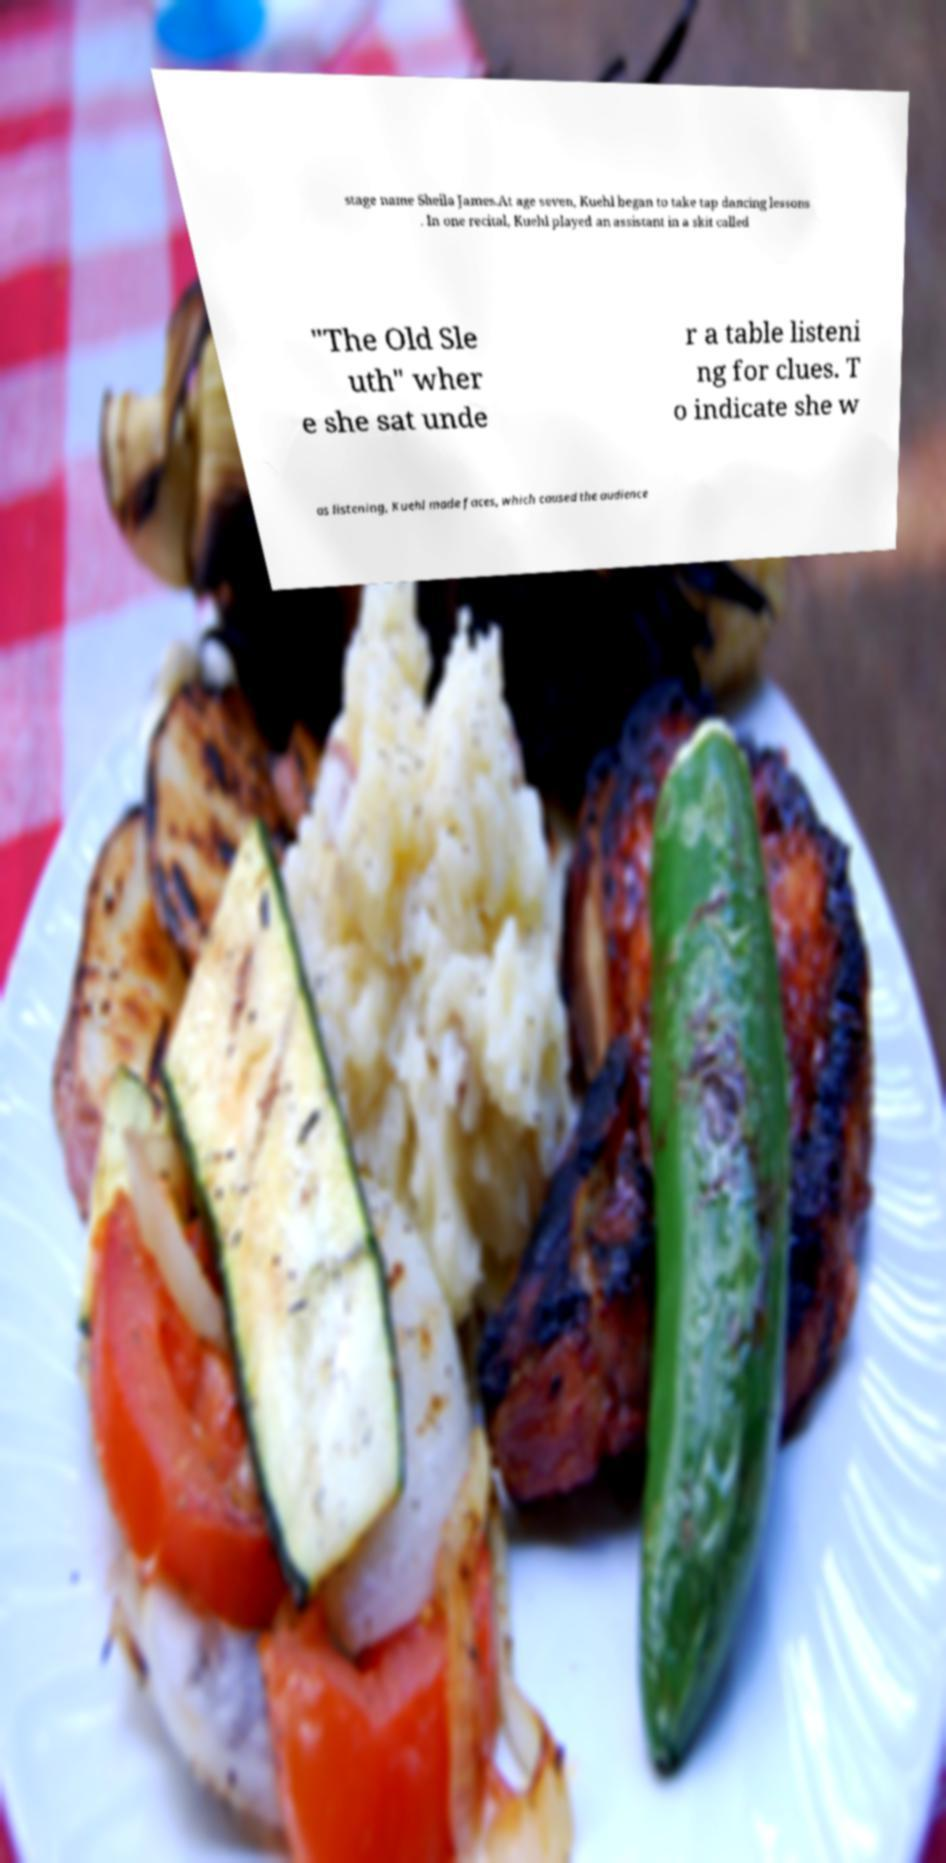I need the written content from this picture converted into text. Can you do that? stage name Sheila James.At age seven, Kuehl began to take tap dancing lessons . In one recital, Kuehl played an assistant in a skit called "The Old Sle uth" wher e she sat unde r a table listeni ng for clues. T o indicate she w as listening, Kuehl made faces, which caused the audience 